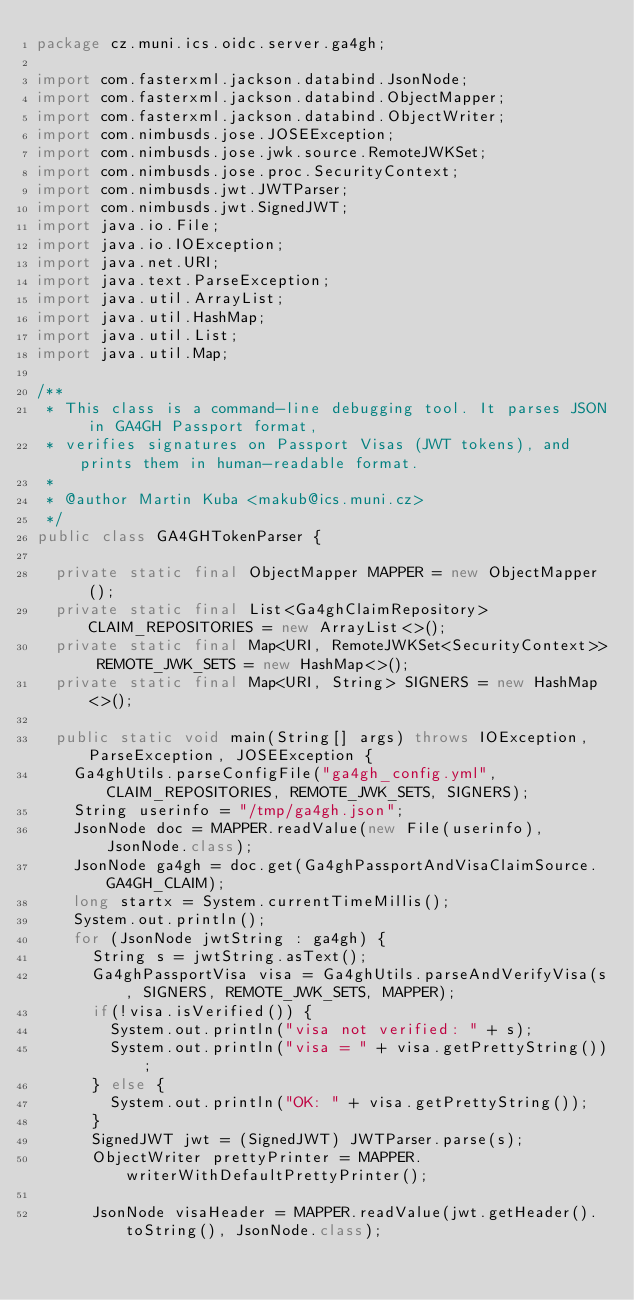<code> <loc_0><loc_0><loc_500><loc_500><_Java_>package cz.muni.ics.oidc.server.ga4gh;

import com.fasterxml.jackson.databind.JsonNode;
import com.fasterxml.jackson.databind.ObjectMapper;
import com.fasterxml.jackson.databind.ObjectWriter;
import com.nimbusds.jose.JOSEException;
import com.nimbusds.jose.jwk.source.RemoteJWKSet;
import com.nimbusds.jose.proc.SecurityContext;
import com.nimbusds.jwt.JWTParser;
import com.nimbusds.jwt.SignedJWT;
import java.io.File;
import java.io.IOException;
import java.net.URI;
import java.text.ParseException;
import java.util.ArrayList;
import java.util.HashMap;
import java.util.List;
import java.util.Map;

/**
 * This class is a command-line debugging tool. It parses JSON in GA4GH Passport format,
 * verifies signatures on Passport Visas (JWT tokens), and prints them in human-readable format.
 *
 * @author Martin Kuba <makub@ics.muni.cz>
 */
public class GA4GHTokenParser {

	private static final ObjectMapper MAPPER = new ObjectMapper();
	private static final List<Ga4ghClaimRepository> CLAIM_REPOSITORIES = new ArrayList<>();
	private static final Map<URI, RemoteJWKSet<SecurityContext>> REMOTE_JWK_SETS = new HashMap<>();
	private static final Map<URI, String> SIGNERS = new HashMap<>();

	public static void main(String[] args) throws IOException, ParseException, JOSEException {
		Ga4ghUtils.parseConfigFile("ga4gh_config.yml", CLAIM_REPOSITORIES, REMOTE_JWK_SETS, SIGNERS);
		String userinfo = "/tmp/ga4gh.json";
		JsonNode doc = MAPPER.readValue(new File(userinfo), JsonNode.class);
		JsonNode ga4gh = doc.get(Ga4ghPassportAndVisaClaimSource.GA4GH_CLAIM);
		long startx = System.currentTimeMillis();
		System.out.println();
		for (JsonNode jwtString : ga4gh) {
			String s = jwtString.asText();
			Ga4ghPassportVisa visa = Ga4ghUtils.parseAndVerifyVisa(s, SIGNERS, REMOTE_JWK_SETS, MAPPER);
			if(!visa.isVerified()) {
				System.out.println("visa not verified: " + s);
				System.out.println("visa = " + visa.getPrettyString());
			} else {
				System.out.println("OK: " + visa.getPrettyString());
			}
			SignedJWT jwt = (SignedJWT) JWTParser.parse(s);
			ObjectWriter prettyPrinter = MAPPER.writerWithDefaultPrettyPrinter();

			JsonNode visaHeader = MAPPER.readValue(jwt.getHeader().toString(), JsonNode.class);</code> 